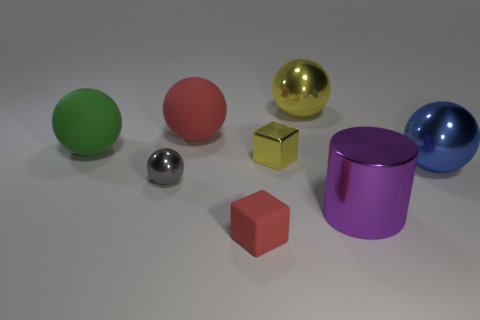Do the big sphere to the left of the big red rubber object and the yellow thing that is on the right side of the tiny yellow block have the same material?
Your answer should be compact. No. What is the color of the metal cube?
Your response must be concise. Yellow. There is a red matte thing on the right side of the red thing that is to the left of the red thing that is in front of the small gray shiny ball; how big is it?
Your response must be concise. Small. How many other things are there of the same size as the green matte sphere?
Make the answer very short. 4. How many large yellow balls have the same material as the small red thing?
Offer a very short reply. 0. What is the shape of the big matte object to the right of the tiny gray object?
Keep it short and to the point. Sphere. Is the tiny ball made of the same material as the red thing in front of the cylinder?
Ensure brevity in your answer.  No. Are any metal objects visible?
Give a very brief answer. Yes. There is a big matte thing in front of the matte ball on the right side of the large green object; is there a red thing that is behind it?
Provide a short and direct response. Yes. How many large objects are either yellow shiny blocks or yellow shiny balls?
Offer a very short reply. 1. 